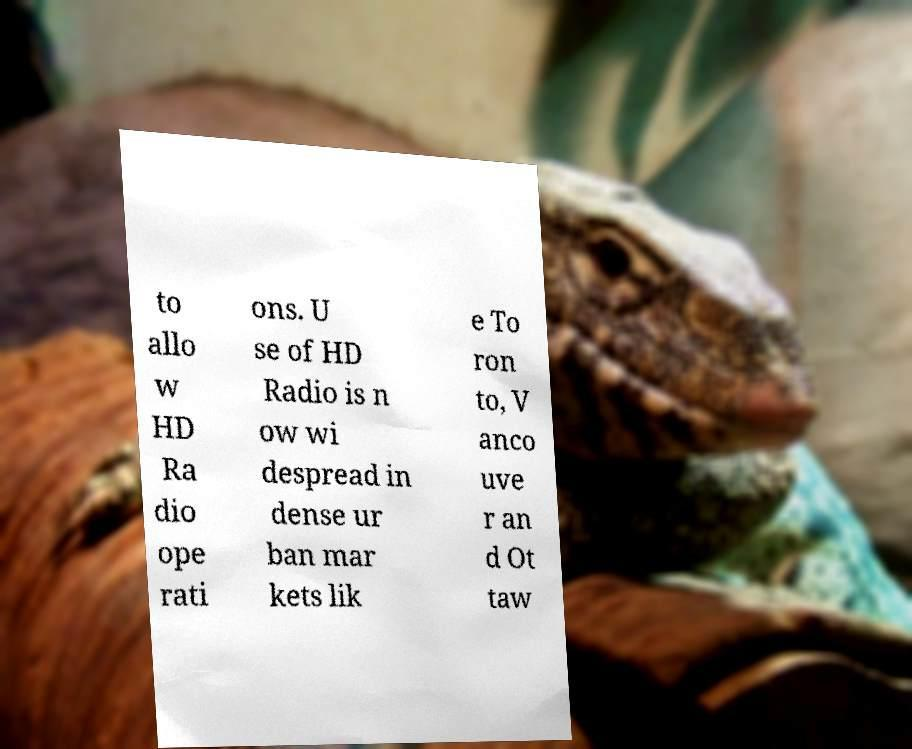I need the written content from this picture converted into text. Can you do that? to allo w HD Ra dio ope rati ons. U se of HD Radio is n ow wi despread in dense ur ban mar kets lik e To ron to, V anco uve r an d Ot taw 